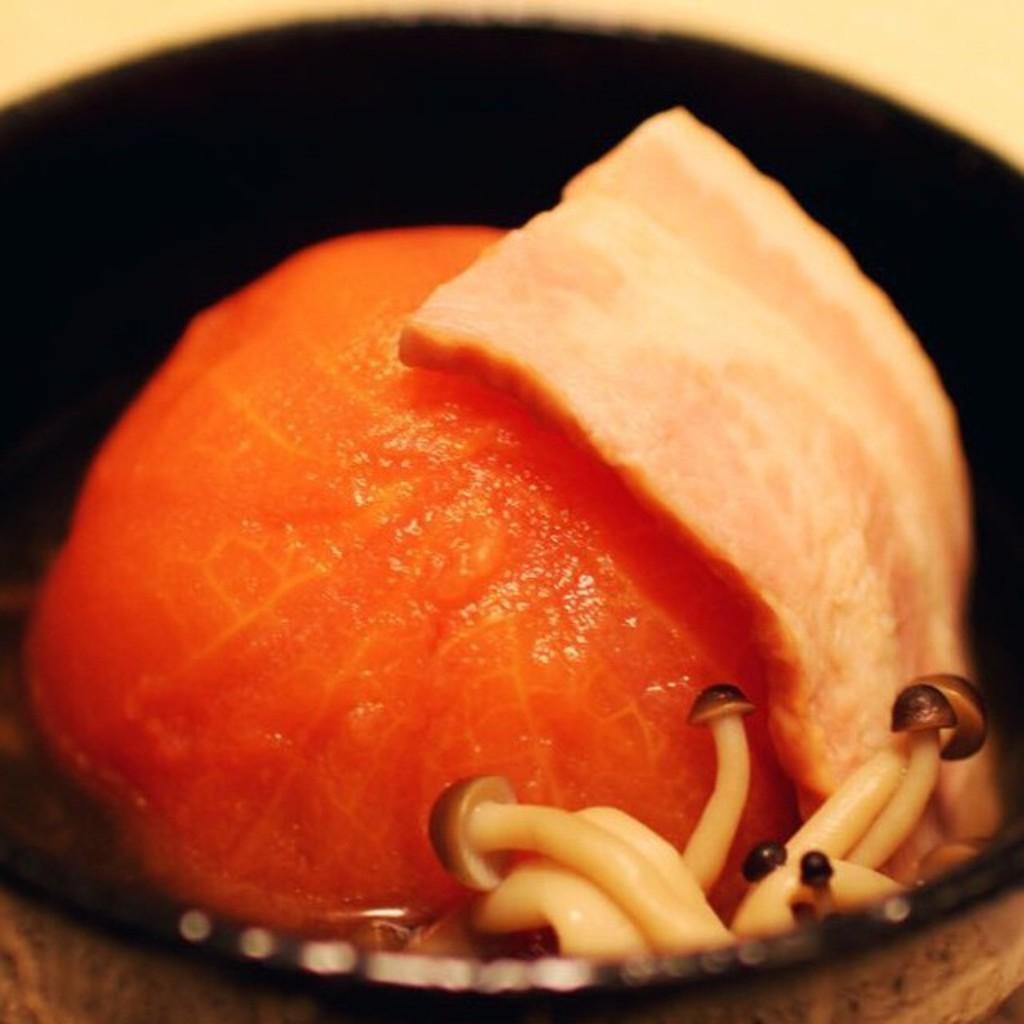In one or two sentences, can you explain what this image depicts? In this picture we can see food and mushrooms in a bowl. In the background of the image it is cream color. 